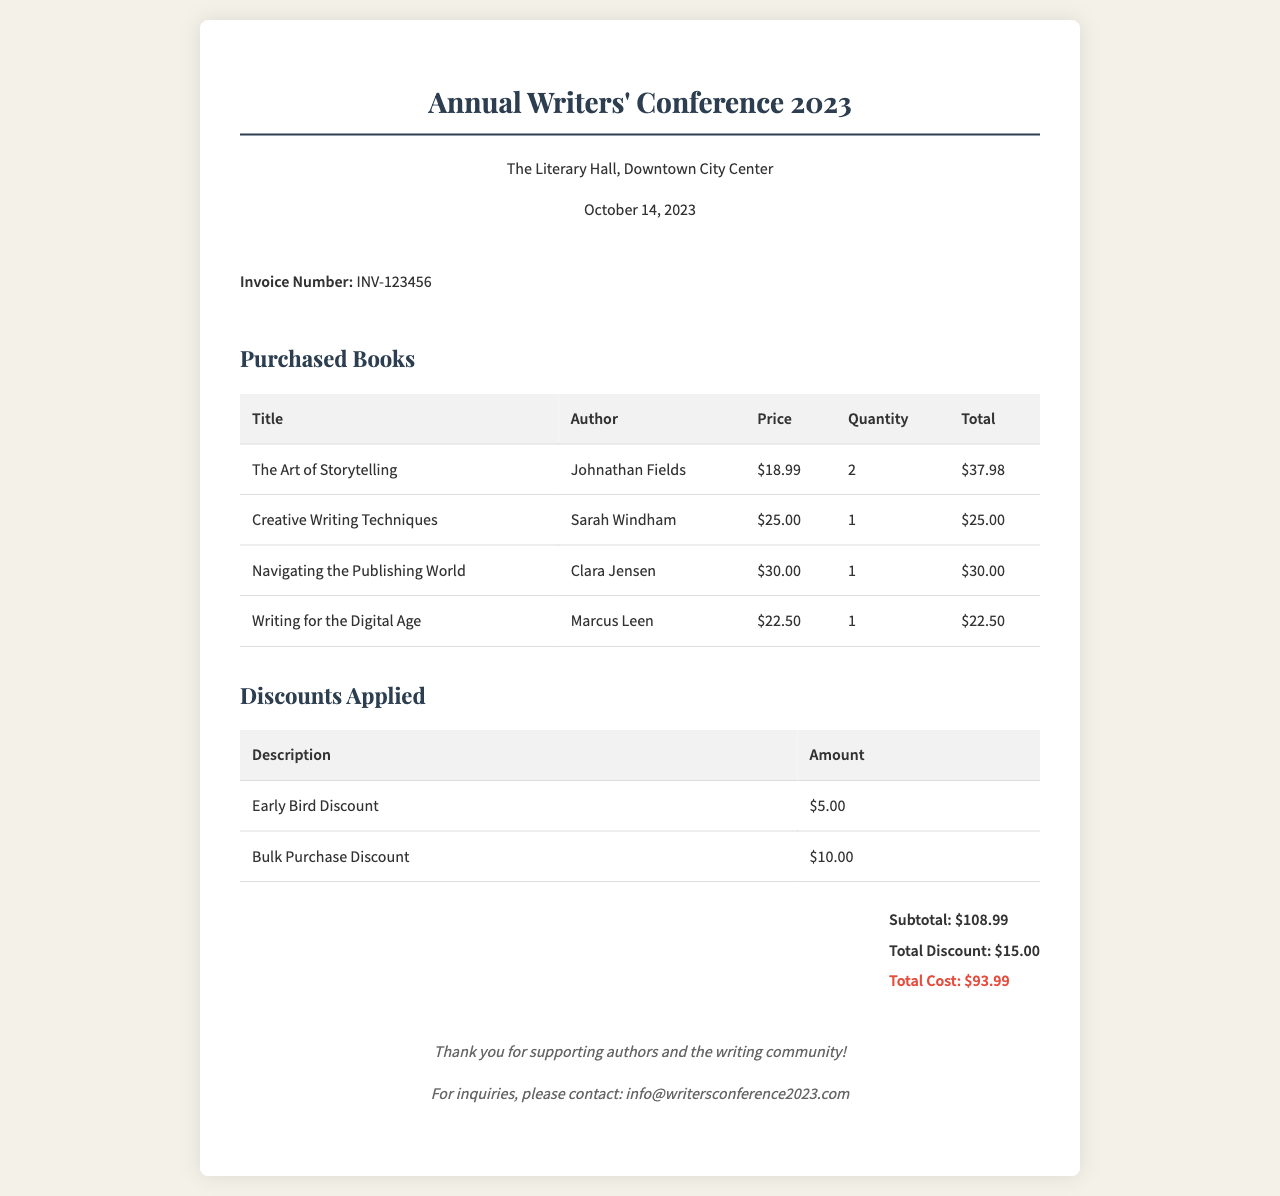What is the invoice number? The invoice number is specifically mentioned in the invoice details section of the document.
Answer: INV-123456 Who is the author of "Creative Writing Techniques"? The author of this book is stated in the purchased books table.
Answer: Sarah Windham What is the total cost after discounts? The total cost is calculated by subtracting the total discounts from the subtotal, which is detailed at the end of the document.
Answer: $93.99 How many copies of "The Art of Storytelling" were purchased? The quantity purchased is listed in the table under the respective book title.
Answer: 2 What discount was applied for early bird registration? The discounts applied are clearly outlined in the discounts table in the document.
Answer: $5.00 What is the total number of books purchased? This is determined by adding the quantities of all books listed in the purchased books section.
Answer: 5 